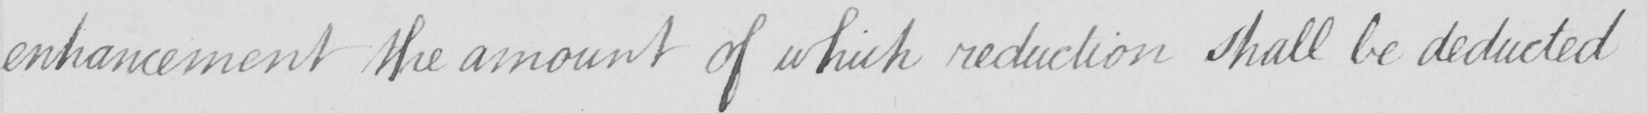Please transcribe the handwritten text in this image. enhancement the amount of which reduction shall be deducted 